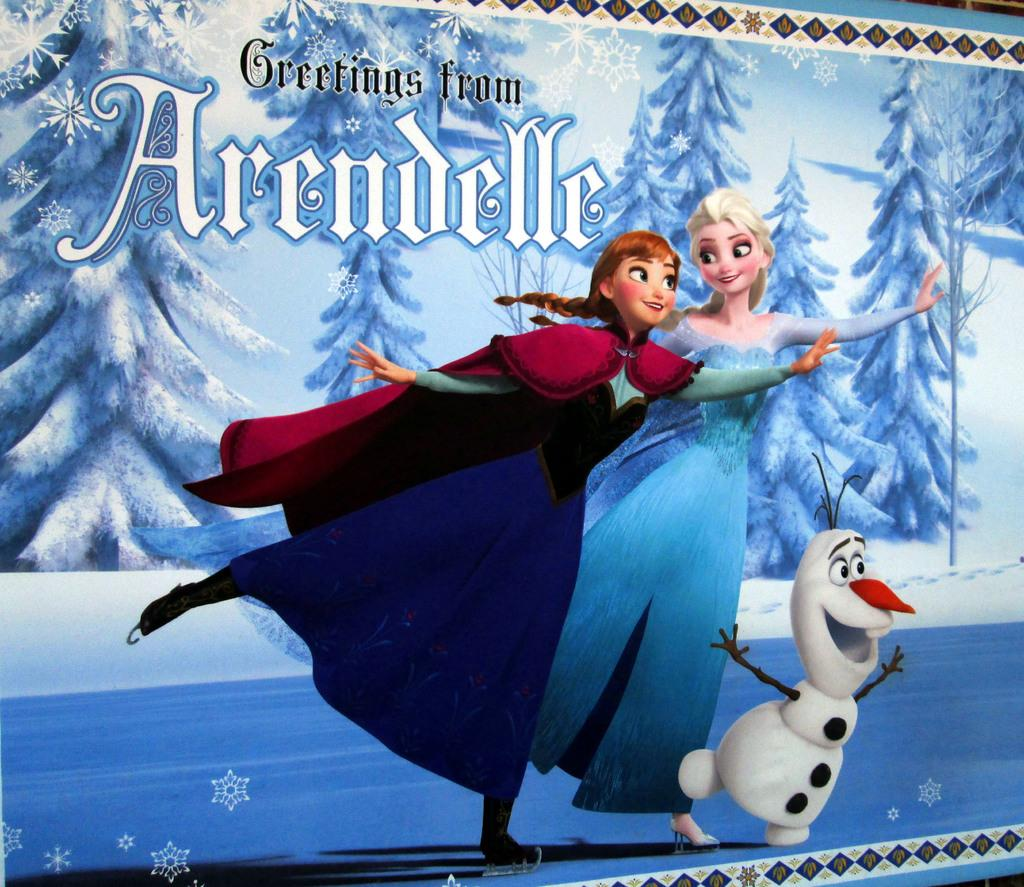<image>
Share a concise interpretation of the image provided. A poster with characters from the movie frozen that reads Greetings from Arrendelle. 